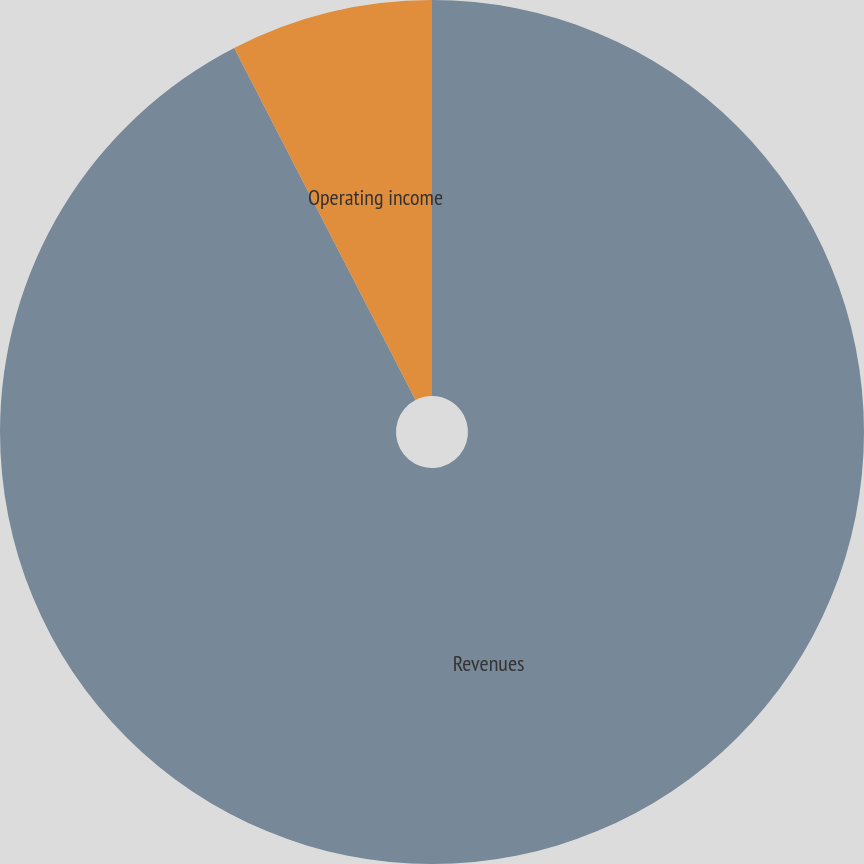Convert chart. <chart><loc_0><loc_0><loc_500><loc_500><pie_chart><fcel>Revenues<fcel>Operating income<nl><fcel>92.43%<fcel>7.57%<nl></chart> 